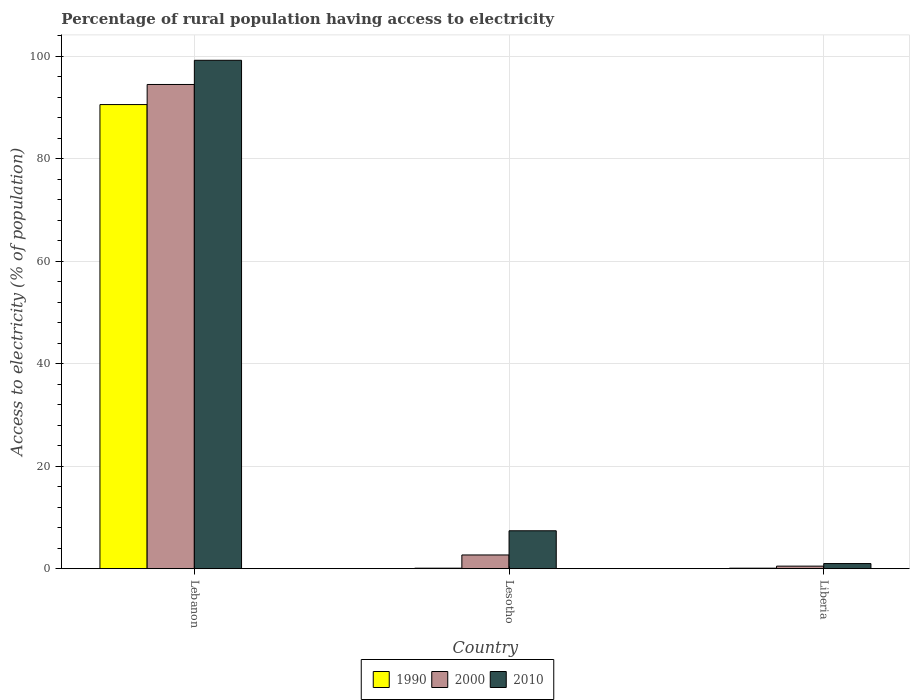How many different coloured bars are there?
Give a very brief answer. 3. Are the number of bars on each tick of the X-axis equal?
Make the answer very short. Yes. How many bars are there on the 1st tick from the right?
Keep it short and to the point. 3. What is the label of the 2nd group of bars from the left?
Your response must be concise. Lesotho. In how many cases, is the number of bars for a given country not equal to the number of legend labels?
Offer a very short reply. 0. What is the percentage of rural population having access to electricity in 2010 in Liberia?
Make the answer very short. 1. Across all countries, what is the maximum percentage of rural population having access to electricity in 1990?
Your answer should be very brief. 90.56. In which country was the percentage of rural population having access to electricity in 1990 maximum?
Provide a succinct answer. Lebanon. In which country was the percentage of rural population having access to electricity in 2000 minimum?
Provide a short and direct response. Liberia. What is the total percentage of rural population having access to electricity in 2000 in the graph?
Ensure brevity in your answer.  97.66. What is the difference between the percentage of rural population having access to electricity in 2010 in Lebanon and that in Lesotho?
Offer a very short reply. 91.8. What is the difference between the percentage of rural population having access to electricity in 2000 in Lebanon and the percentage of rural population having access to electricity in 1990 in Lesotho?
Your answer should be compact. 94.38. What is the average percentage of rural population having access to electricity in 2000 per country?
Your answer should be very brief. 32.55. What is the difference between the percentage of rural population having access to electricity of/in 2000 and percentage of rural population having access to electricity of/in 1990 in Lebanon?
Provide a succinct answer. 3.92. Is the percentage of rural population having access to electricity in 2010 in Lebanon less than that in Lesotho?
Keep it short and to the point. No. Is the difference between the percentage of rural population having access to electricity in 2000 in Lebanon and Lesotho greater than the difference between the percentage of rural population having access to electricity in 1990 in Lebanon and Lesotho?
Keep it short and to the point. Yes. What is the difference between the highest and the second highest percentage of rural population having access to electricity in 1990?
Provide a succinct answer. -90.46. What is the difference between the highest and the lowest percentage of rural population having access to electricity in 1990?
Offer a very short reply. 90.46. In how many countries, is the percentage of rural population having access to electricity in 1990 greater than the average percentage of rural population having access to electricity in 1990 taken over all countries?
Your answer should be compact. 1. Is the sum of the percentage of rural population having access to electricity in 2000 in Lesotho and Liberia greater than the maximum percentage of rural population having access to electricity in 1990 across all countries?
Provide a succinct answer. No. What does the 1st bar from the left in Lesotho represents?
Your answer should be compact. 1990. What does the 3rd bar from the right in Liberia represents?
Your answer should be very brief. 1990. Are all the bars in the graph horizontal?
Provide a short and direct response. No. How many countries are there in the graph?
Your response must be concise. 3. What is the difference between two consecutive major ticks on the Y-axis?
Your response must be concise. 20. Does the graph contain grids?
Offer a very short reply. Yes. How are the legend labels stacked?
Your answer should be very brief. Horizontal. What is the title of the graph?
Offer a terse response. Percentage of rural population having access to electricity. Does "1963" appear as one of the legend labels in the graph?
Provide a succinct answer. No. What is the label or title of the X-axis?
Give a very brief answer. Country. What is the label or title of the Y-axis?
Provide a succinct answer. Access to electricity (% of population). What is the Access to electricity (% of population) in 1990 in Lebanon?
Make the answer very short. 90.56. What is the Access to electricity (% of population) in 2000 in Lebanon?
Offer a very short reply. 94.48. What is the Access to electricity (% of population) of 2010 in Lebanon?
Offer a very short reply. 99.2. What is the Access to electricity (% of population) in 1990 in Lesotho?
Give a very brief answer. 0.1. What is the Access to electricity (% of population) of 2000 in Lesotho?
Your answer should be very brief. 2.68. What is the Access to electricity (% of population) in 2010 in Lesotho?
Offer a very short reply. 7.4. What is the Access to electricity (% of population) of 2000 in Liberia?
Provide a short and direct response. 0.5. What is the Access to electricity (% of population) in 2010 in Liberia?
Your answer should be compact. 1. Across all countries, what is the maximum Access to electricity (% of population) in 1990?
Your answer should be very brief. 90.56. Across all countries, what is the maximum Access to electricity (% of population) in 2000?
Keep it short and to the point. 94.48. Across all countries, what is the maximum Access to electricity (% of population) in 2010?
Your answer should be compact. 99.2. Across all countries, what is the minimum Access to electricity (% of population) of 1990?
Keep it short and to the point. 0.1. Across all countries, what is the minimum Access to electricity (% of population) in 2000?
Make the answer very short. 0.5. What is the total Access to electricity (% of population) in 1990 in the graph?
Your response must be concise. 90.76. What is the total Access to electricity (% of population) of 2000 in the graph?
Your answer should be compact. 97.66. What is the total Access to electricity (% of population) of 2010 in the graph?
Your answer should be very brief. 107.6. What is the difference between the Access to electricity (% of population) in 1990 in Lebanon and that in Lesotho?
Your answer should be compact. 90.46. What is the difference between the Access to electricity (% of population) of 2000 in Lebanon and that in Lesotho?
Your answer should be compact. 91.8. What is the difference between the Access to electricity (% of population) of 2010 in Lebanon and that in Lesotho?
Offer a very short reply. 91.8. What is the difference between the Access to electricity (% of population) in 1990 in Lebanon and that in Liberia?
Your answer should be compact. 90.46. What is the difference between the Access to electricity (% of population) in 2000 in Lebanon and that in Liberia?
Offer a terse response. 93.98. What is the difference between the Access to electricity (% of population) of 2010 in Lebanon and that in Liberia?
Your answer should be very brief. 98.2. What is the difference between the Access to electricity (% of population) in 1990 in Lesotho and that in Liberia?
Offer a terse response. 0. What is the difference between the Access to electricity (% of population) of 2000 in Lesotho and that in Liberia?
Provide a succinct answer. 2.18. What is the difference between the Access to electricity (% of population) of 2010 in Lesotho and that in Liberia?
Your response must be concise. 6.4. What is the difference between the Access to electricity (% of population) of 1990 in Lebanon and the Access to electricity (% of population) of 2000 in Lesotho?
Your response must be concise. 87.88. What is the difference between the Access to electricity (% of population) of 1990 in Lebanon and the Access to electricity (% of population) of 2010 in Lesotho?
Offer a very short reply. 83.16. What is the difference between the Access to electricity (% of population) in 2000 in Lebanon and the Access to electricity (% of population) in 2010 in Lesotho?
Make the answer very short. 87.08. What is the difference between the Access to electricity (% of population) in 1990 in Lebanon and the Access to electricity (% of population) in 2000 in Liberia?
Give a very brief answer. 90.06. What is the difference between the Access to electricity (% of population) in 1990 in Lebanon and the Access to electricity (% of population) in 2010 in Liberia?
Provide a succinct answer. 89.56. What is the difference between the Access to electricity (% of population) in 2000 in Lebanon and the Access to electricity (% of population) in 2010 in Liberia?
Make the answer very short. 93.48. What is the difference between the Access to electricity (% of population) of 1990 in Lesotho and the Access to electricity (% of population) of 2000 in Liberia?
Your answer should be very brief. -0.4. What is the difference between the Access to electricity (% of population) of 2000 in Lesotho and the Access to electricity (% of population) of 2010 in Liberia?
Make the answer very short. 1.68. What is the average Access to electricity (% of population) of 1990 per country?
Your answer should be compact. 30.25. What is the average Access to electricity (% of population) of 2000 per country?
Offer a terse response. 32.55. What is the average Access to electricity (% of population) in 2010 per country?
Your answer should be compact. 35.87. What is the difference between the Access to electricity (% of population) of 1990 and Access to electricity (% of population) of 2000 in Lebanon?
Make the answer very short. -3.92. What is the difference between the Access to electricity (% of population) in 1990 and Access to electricity (% of population) in 2010 in Lebanon?
Keep it short and to the point. -8.64. What is the difference between the Access to electricity (% of population) of 2000 and Access to electricity (% of population) of 2010 in Lebanon?
Keep it short and to the point. -4.72. What is the difference between the Access to electricity (% of population) in 1990 and Access to electricity (% of population) in 2000 in Lesotho?
Give a very brief answer. -2.58. What is the difference between the Access to electricity (% of population) in 2000 and Access to electricity (% of population) in 2010 in Lesotho?
Give a very brief answer. -4.72. What is the difference between the Access to electricity (% of population) in 1990 and Access to electricity (% of population) in 2000 in Liberia?
Your answer should be compact. -0.4. What is the difference between the Access to electricity (% of population) in 1990 and Access to electricity (% of population) in 2010 in Liberia?
Ensure brevity in your answer.  -0.9. What is the difference between the Access to electricity (% of population) of 2000 and Access to electricity (% of population) of 2010 in Liberia?
Your answer should be compact. -0.5. What is the ratio of the Access to electricity (% of population) in 1990 in Lebanon to that in Lesotho?
Keep it short and to the point. 905.6. What is the ratio of the Access to electricity (% of population) in 2000 in Lebanon to that in Lesotho?
Offer a terse response. 35.25. What is the ratio of the Access to electricity (% of population) in 2010 in Lebanon to that in Lesotho?
Your answer should be compact. 13.41. What is the ratio of the Access to electricity (% of population) of 1990 in Lebanon to that in Liberia?
Keep it short and to the point. 905.6. What is the ratio of the Access to electricity (% of population) in 2000 in Lebanon to that in Liberia?
Offer a very short reply. 188.96. What is the ratio of the Access to electricity (% of population) in 2010 in Lebanon to that in Liberia?
Offer a very short reply. 99.2. What is the ratio of the Access to electricity (% of population) in 1990 in Lesotho to that in Liberia?
Your answer should be very brief. 1. What is the ratio of the Access to electricity (% of population) in 2000 in Lesotho to that in Liberia?
Your answer should be compact. 5.36. What is the ratio of the Access to electricity (% of population) in 2010 in Lesotho to that in Liberia?
Give a very brief answer. 7.4. What is the difference between the highest and the second highest Access to electricity (% of population) of 1990?
Make the answer very short. 90.46. What is the difference between the highest and the second highest Access to electricity (% of population) of 2000?
Your answer should be compact. 91.8. What is the difference between the highest and the second highest Access to electricity (% of population) of 2010?
Keep it short and to the point. 91.8. What is the difference between the highest and the lowest Access to electricity (% of population) in 1990?
Make the answer very short. 90.46. What is the difference between the highest and the lowest Access to electricity (% of population) in 2000?
Ensure brevity in your answer.  93.98. What is the difference between the highest and the lowest Access to electricity (% of population) in 2010?
Your answer should be compact. 98.2. 